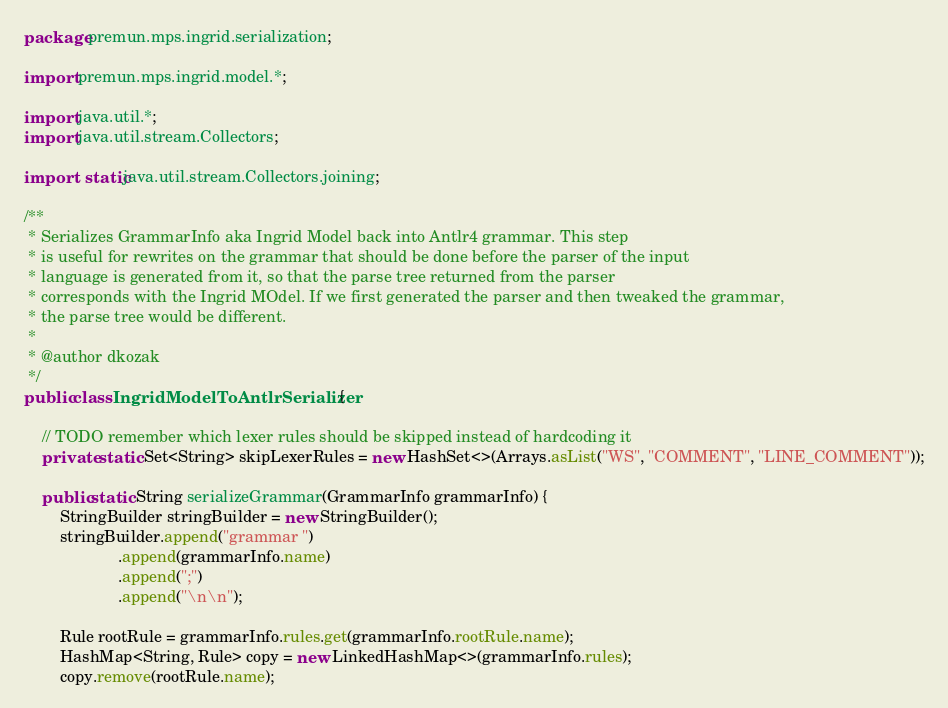Convert code to text. <code><loc_0><loc_0><loc_500><loc_500><_Java_>package premun.mps.ingrid.serialization;

import premun.mps.ingrid.model.*;

import java.util.*;
import java.util.stream.Collectors;

import static java.util.stream.Collectors.joining;

/**
 * Serializes GrammarInfo aka Ingrid Model back into Antlr4 grammar. This step
 * is useful for rewrites on the grammar that should be done before the parser of the input
 * language is generated from it, so that the parse tree returned from the parser
 * corresponds with the Ingrid MOdel. If we first generated the parser and then tweaked the grammar,
 * the parse tree would be different.
 *
 * @author dkozak
 */
public class IngridModelToAntlrSerializer {

    // TODO remember which lexer rules should be skipped instead of hardcoding it
    private static Set<String> skipLexerRules = new HashSet<>(Arrays.asList("WS", "COMMENT", "LINE_COMMENT"));

    public static String serializeGrammar(GrammarInfo grammarInfo) {
        StringBuilder stringBuilder = new StringBuilder();
        stringBuilder.append("grammar ")
                     .append(grammarInfo.name)
                     .append(";")
                     .append("\n\n");

        Rule rootRule = grammarInfo.rules.get(grammarInfo.rootRule.name);
        HashMap<String, Rule> copy = new LinkedHashMap<>(grammarInfo.rules);
        copy.remove(rootRule.name);
</code> 